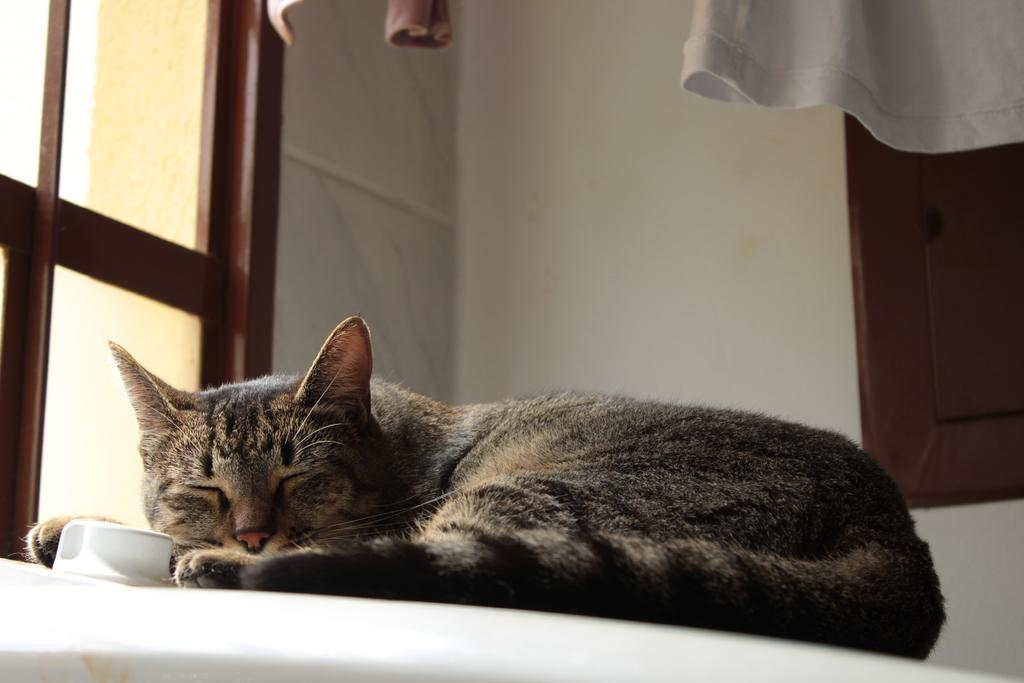What is the main subject in the center of the image? There is a cat in the center of the image. What can be seen at the top of the image? There is a wall, clothes, and windows visible at the top of the image. What type of metal is the cat using to create a rhythm in the image? There is no metal or rhythm present in the image; it features a cat and other elements at the top of the image. 